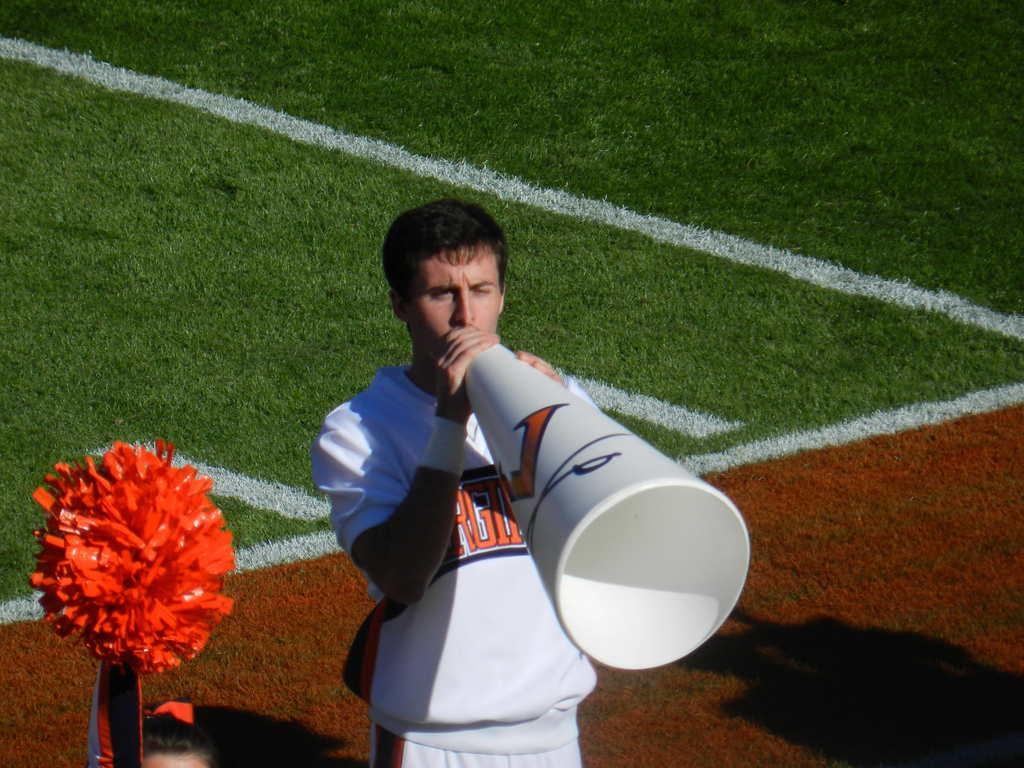How many people are in the image? There are two persons in the image. Can you describe the gender of one of the persons? One of the persons is a woman. What is the woman holding in the image? The woman is holding a pom pom. What is the other person holding in the image? The other person is holding a pipe. Where are the persons standing in the image? The persons are standing on the ground. What type of trouble is the woman causing with her pom pom in the image? There is no indication of trouble or any negative actions in the image; the woman is simply holding a pom pom. Can you tell me how many verses the pipe is reciting in the image? There is no indication of any verses or recitation in the image; the person is simply holding a pipe. 